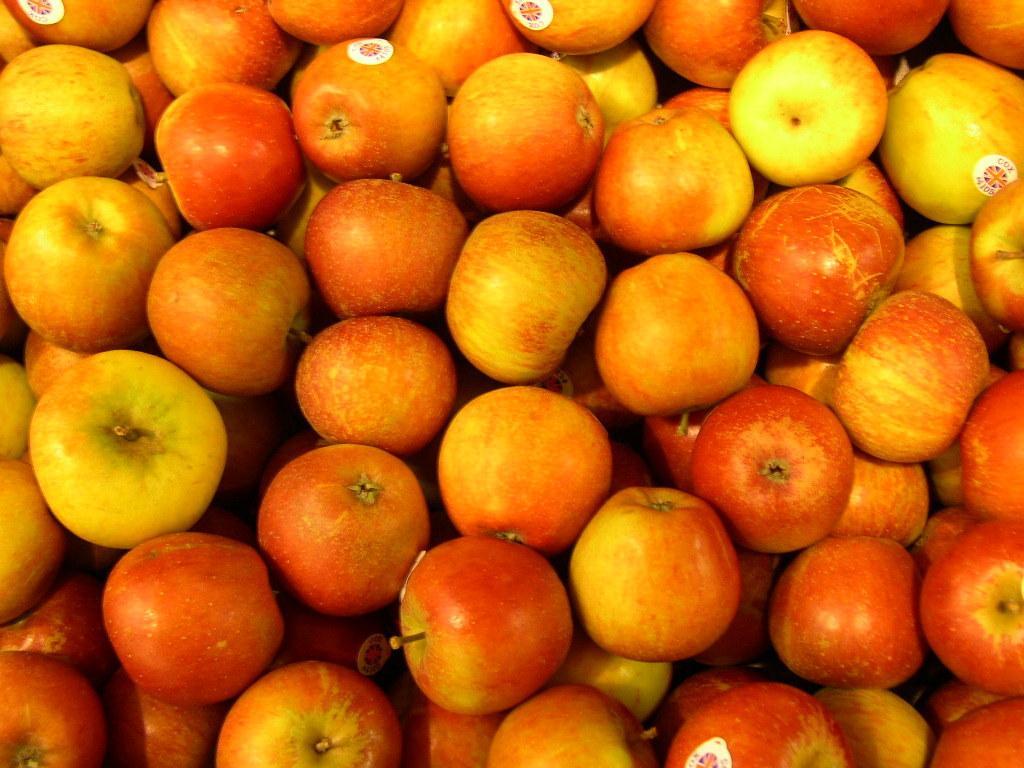Describe this image in one or two sentences. This image consists of many apples. And there are stickers on the apples. 